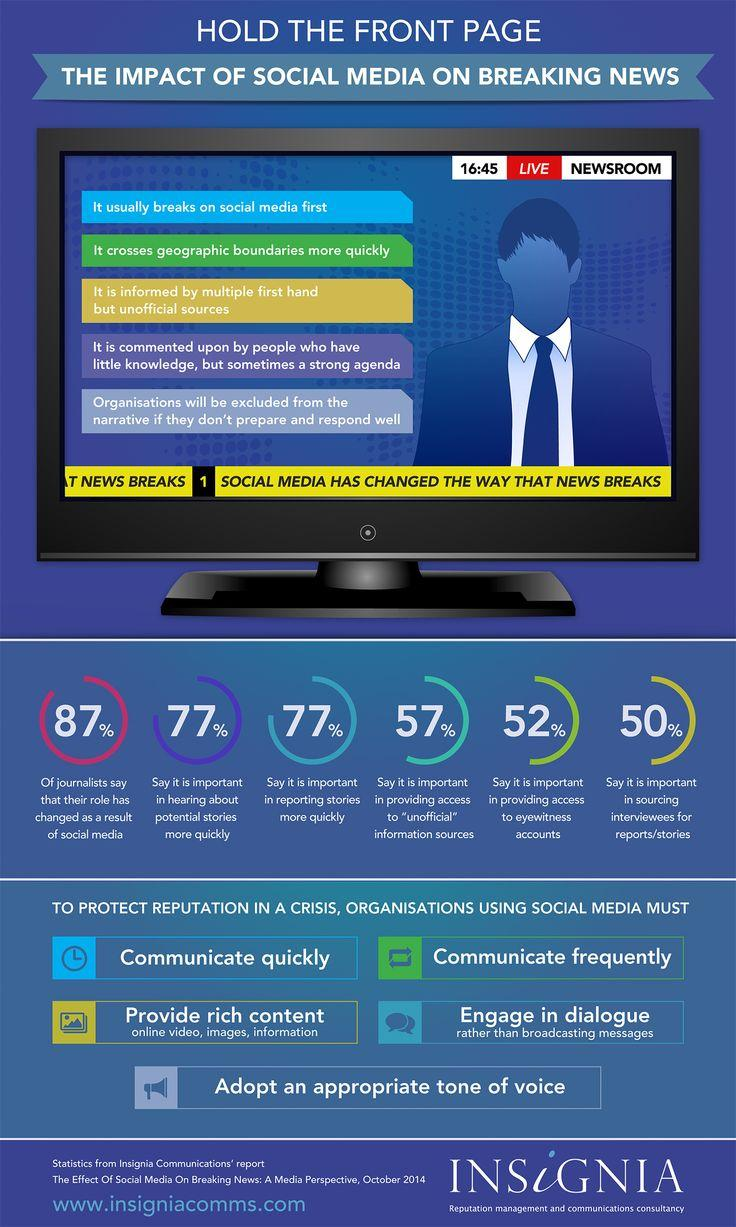Draw attention to some important aspects in this diagram. According to a survey of journalists, 77% believe that social media is important in reporting stories more quickly. Eighty-seven percent of journalists believe that their role has been impacted by social media. According to a survey of journalists, a majority of 52% believe that social media is important in providing access to eyewitness accounts. 